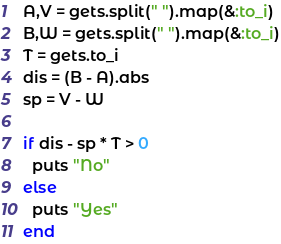Convert code to text. <code><loc_0><loc_0><loc_500><loc_500><_Ruby_>A,V = gets.split(" ").map(&:to_i)
B,W = gets.split(" ").map(&:to_i)
T = gets.to_i
dis = (B - A).abs
sp = V - W

if dis - sp * T > 0
  puts "No"
else
  puts "Yes"
end</code> 